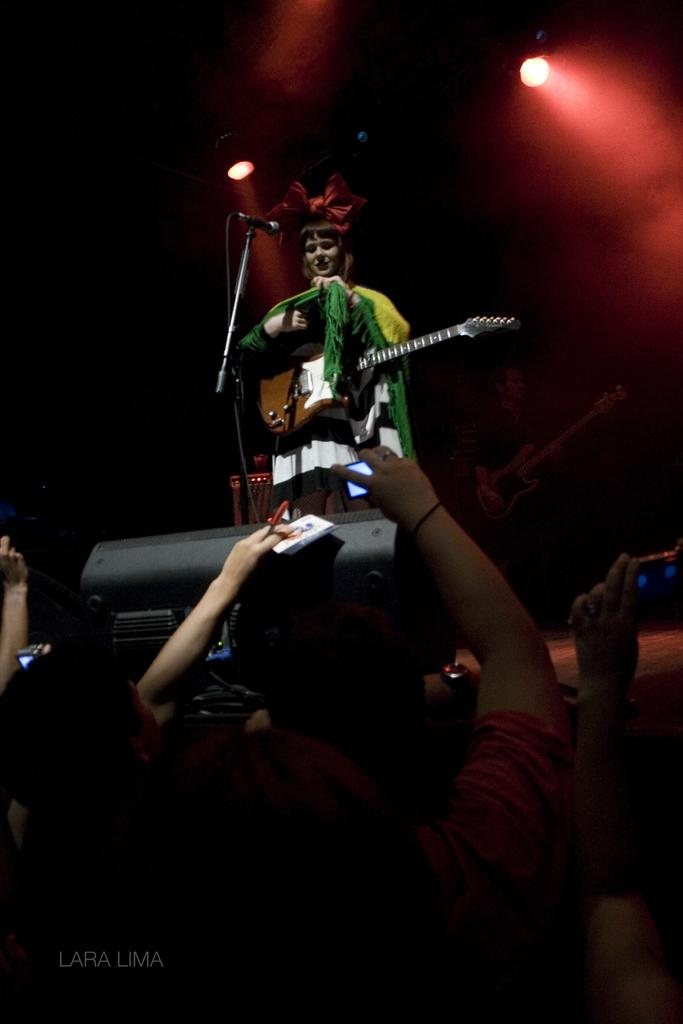What is the main activity of the people in the image? The people in the image are standing, which suggests they might be waiting or attending an event. Can you describe the woman in the image? The woman in the image is standing and carrying a guitar. What object is present in the image that is typically used for amplifying sound? There is a microphone in the image. What can be seen in the image that might provide illumination? There is a light in the image. What type of payment is being made by the doctor in the image? There is no doctor or payment present in the image. How does the man in the image contribute to the performance? There is no man present in the image, so it is not possible to determine his contribution to the performance. 